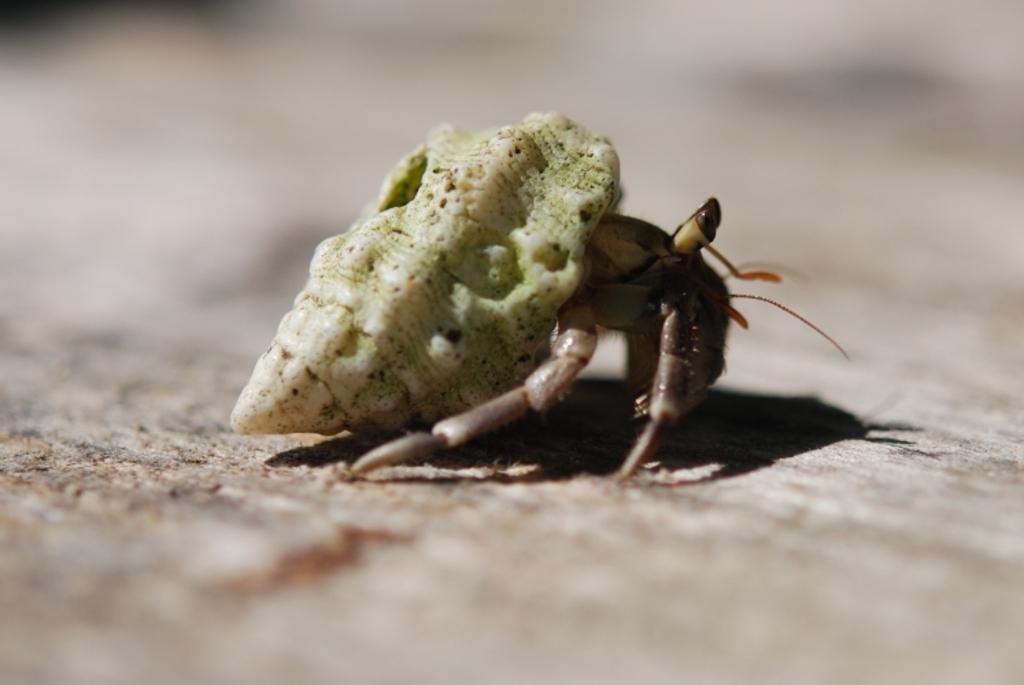In one or two sentences, can you explain what this image depicts? On this surface we can see an insect. Background it is blur. 